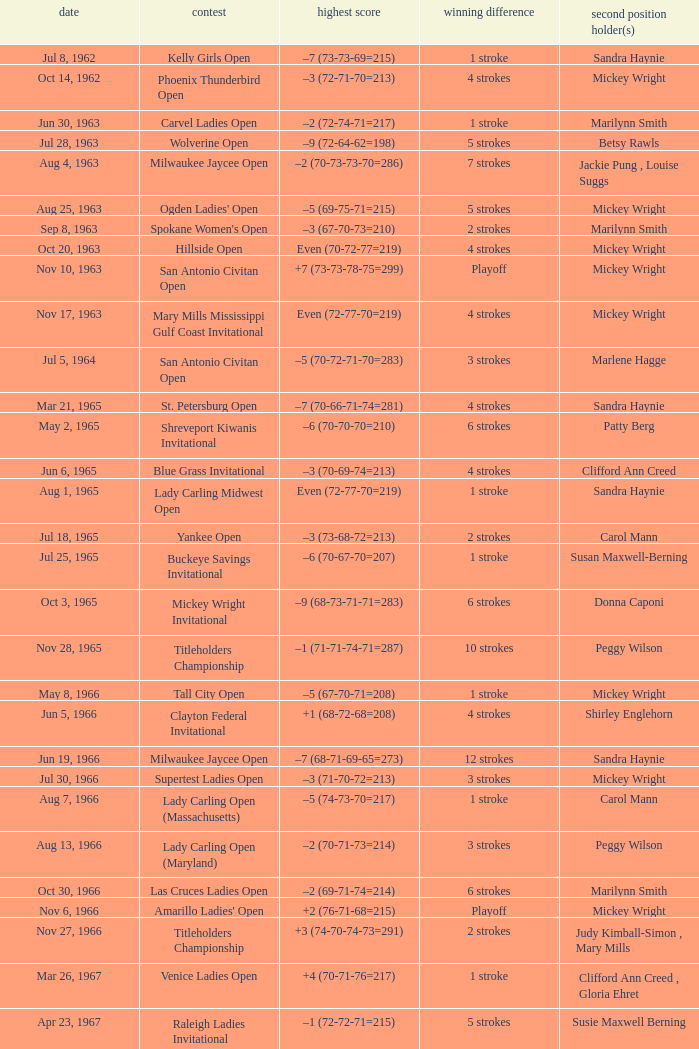What was the margin of victory on Apr 23, 1967? 5 strokes. 